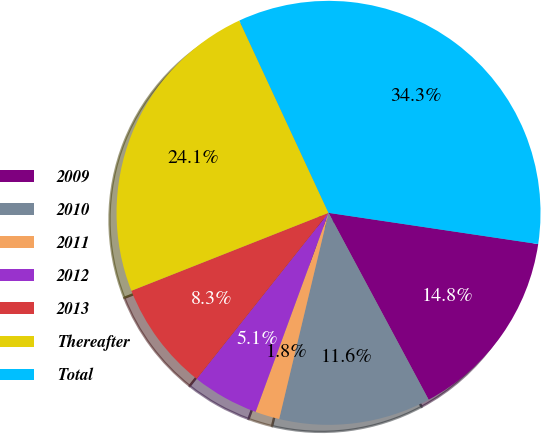<chart> <loc_0><loc_0><loc_500><loc_500><pie_chart><fcel>2009<fcel>2010<fcel>2011<fcel>2012<fcel>2013<fcel>Thereafter<fcel>Total<nl><fcel>14.82%<fcel>11.57%<fcel>1.85%<fcel>5.09%<fcel>8.33%<fcel>24.08%<fcel>34.27%<nl></chart> 